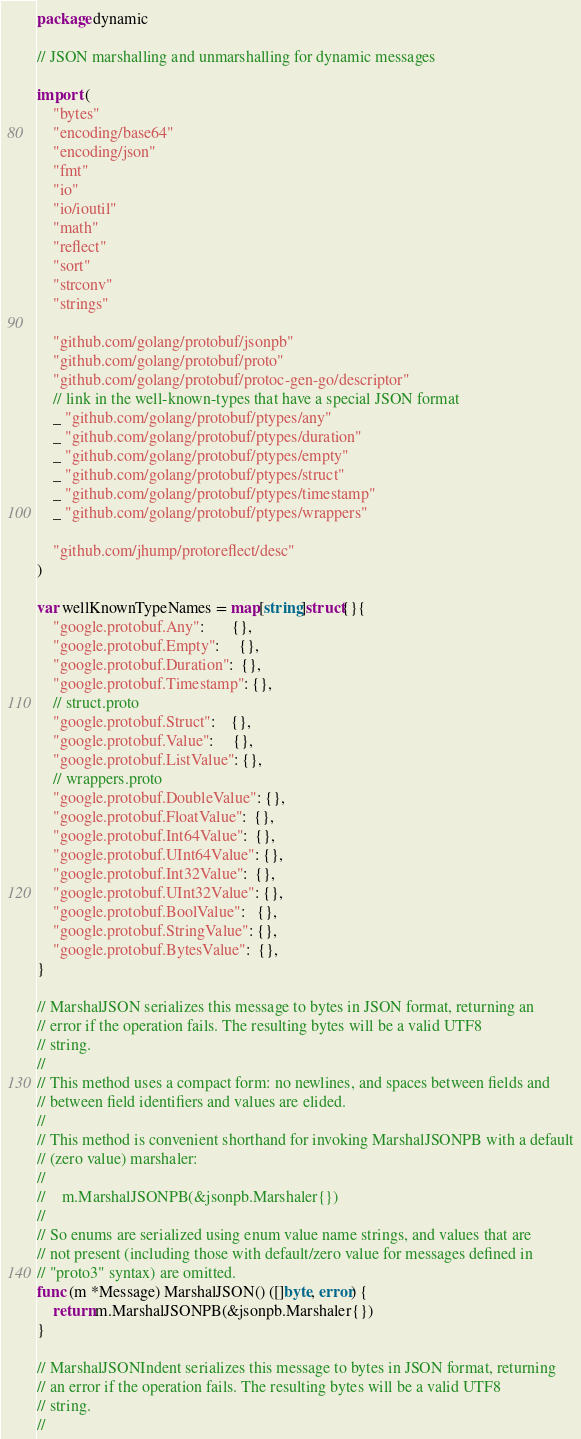Convert code to text. <code><loc_0><loc_0><loc_500><loc_500><_Go_>package dynamic

// JSON marshalling and unmarshalling for dynamic messages

import (
	"bytes"
	"encoding/base64"
	"encoding/json"
	"fmt"
	"io"
	"io/ioutil"
	"math"
	"reflect"
	"sort"
	"strconv"
	"strings"

	"github.com/golang/protobuf/jsonpb"
	"github.com/golang/protobuf/proto"
	"github.com/golang/protobuf/protoc-gen-go/descriptor"
	// link in the well-known-types that have a special JSON format
	_ "github.com/golang/protobuf/ptypes/any"
	_ "github.com/golang/protobuf/ptypes/duration"
	_ "github.com/golang/protobuf/ptypes/empty"
	_ "github.com/golang/protobuf/ptypes/struct"
	_ "github.com/golang/protobuf/ptypes/timestamp"
	_ "github.com/golang/protobuf/ptypes/wrappers"

	"github.com/jhump/protoreflect/desc"
)

var wellKnownTypeNames = map[string]struct{}{
	"google.protobuf.Any":       {},
	"google.protobuf.Empty":     {},
	"google.protobuf.Duration":  {},
	"google.protobuf.Timestamp": {},
	// struct.proto
	"google.protobuf.Struct":    {},
	"google.protobuf.Value":     {},
	"google.protobuf.ListValue": {},
	// wrappers.proto
	"google.protobuf.DoubleValue": {},
	"google.protobuf.FloatValue":  {},
	"google.protobuf.Int64Value":  {},
	"google.protobuf.UInt64Value": {},
	"google.protobuf.Int32Value":  {},
	"google.protobuf.UInt32Value": {},
	"google.protobuf.BoolValue":   {},
	"google.protobuf.StringValue": {},
	"google.protobuf.BytesValue":  {},
}

// MarshalJSON serializes this message to bytes in JSON format, returning an
// error if the operation fails. The resulting bytes will be a valid UTF8
// string.
//
// This method uses a compact form: no newlines, and spaces between fields and
// between field identifiers and values are elided.
//
// This method is convenient shorthand for invoking MarshalJSONPB with a default
// (zero value) marshaler:
//
//    m.MarshalJSONPB(&jsonpb.Marshaler{})
//
// So enums are serialized using enum value name strings, and values that are
// not present (including those with default/zero value for messages defined in
// "proto3" syntax) are omitted.
func (m *Message) MarshalJSON() ([]byte, error) {
	return m.MarshalJSONPB(&jsonpb.Marshaler{})
}

// MarshalJSONIndent serializes this message to bytes in JSON format, returning
// an error if the operation fails. The resulting bytes will be a valid UTF8
// string.
//</code> 